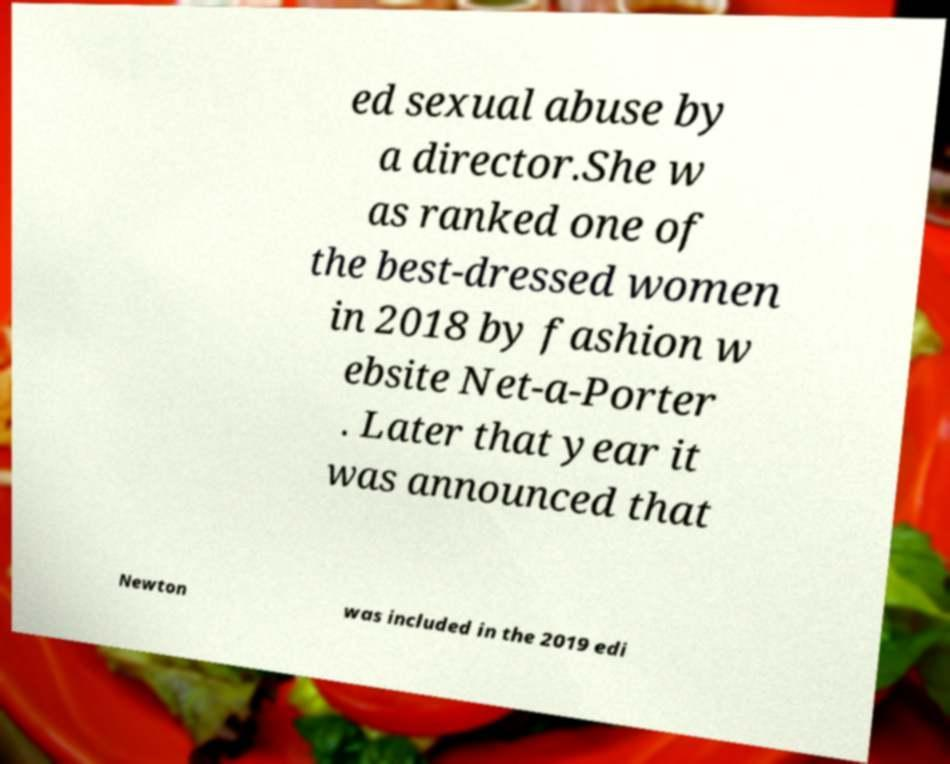Please identify and transcribe the text found in this image. ed sexual abuse by a director.She w as ranked one of the best-dressed women in 2018 by fashion w ebsite Net-a-Porter . Later that year it was announced that Newton was included in the 2019 edi 